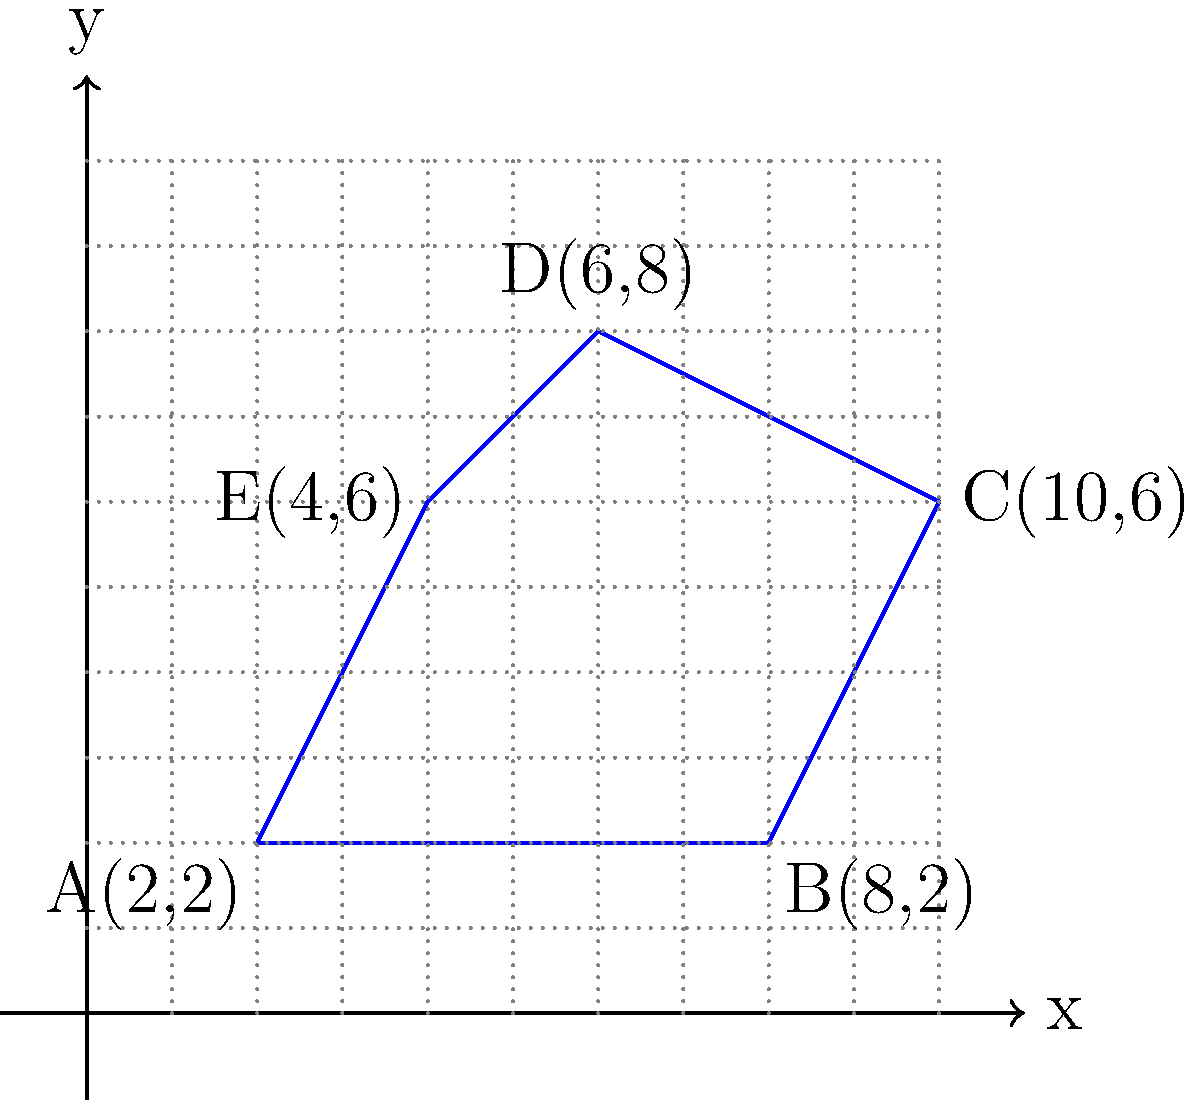As a litigator representing a workers' union, you're analyzing the layout of a tech company's workplace. The diagram shows an irregularly shaped zone where employees work. Using coordinate geometry, calculate the area of this workplace zone. The coordinates of the vertices are A(2,2), B(8,2), C(10,6), D(6,8), and E(4,6). Express your answer in square units. To calculate the area of this irregular polygon, we can use the Shoelace formula (also known as the surveyor's formula). The steps are as follows:

1) List the coordinates in order (either clockwise or counterclockwise):
   (2,2), (8,2), (10,6), (6,8), (4,6)

2) Apply the Shoelace formula:
   Area = $\frac{1}{2}|\sum_{i=1}^{n-1} (x_i y_{i+1} + x_n y_1) - \sum_{i=1}^{n-1} (y_i x_{i+1} + y_n x_1)|$

3) Calculate each term:
   $(2 \cdot 2) + (8 \cdot 6) + (10 \cdot 8) + (6 \cdot 6) + (4 \cdot 2) = 4 + 48 + 80 + 36 + 8 = 176$
   $(2 \cdot 8) + (2 \cdot 10) + (6 \cdot 6) + (8 \cdot 4) + (6 \cdot 2) = 16 + 20 + 36 + 32 + 12 = 116$

4) Subtract and take the absolute value:
   $|176 - 116| = 60$

5) Divide by 2:
   $\frac{60}{2} = 30$

Therefore, the area of the workplace zone is 30 square units.
Answer: 30 square units 